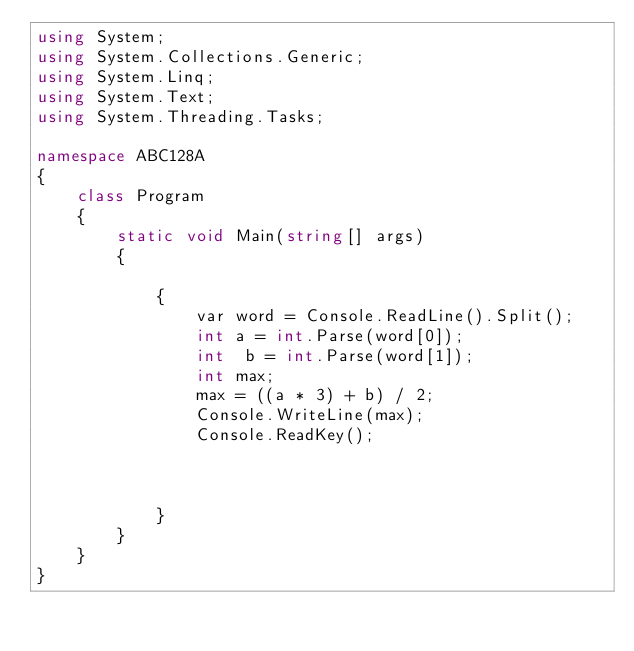<code> <loc_0><loc_0><loc_500><loc_500><_C#_>using System;
using System.Collections.Generic;
using System.Linq;
using System.Text;
using System.Threading.Tasks;

namespace ABC128A
{
    class Program
    {
        static void Main(string[] args)
        {
          
            {
                var word = Console.ReadLine().Split();
                int a = int.Parse(word[0]);
                int  b = int.Parse(word[1]);
                int max;
                max = ((a * 3) + b) / 2;
                Console.WriteLine(max);
                Console.ReadKey();



            }
        }
    }
}
    


</code> 